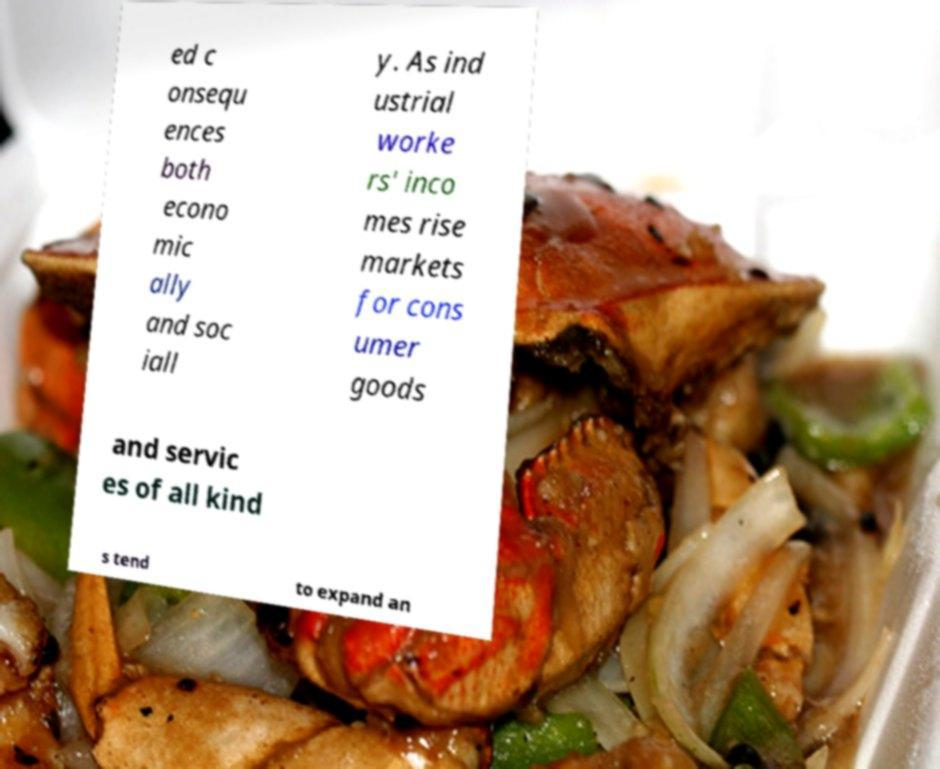For documentation purposes, I need the text within this image transcribed. Could you provide that? ed c onsequ ences both econo mic ally and soc iall y. As ind ustrial worke rs' inco mes rise markets for cons umer goods and servic es of all kind s tend to expand an 